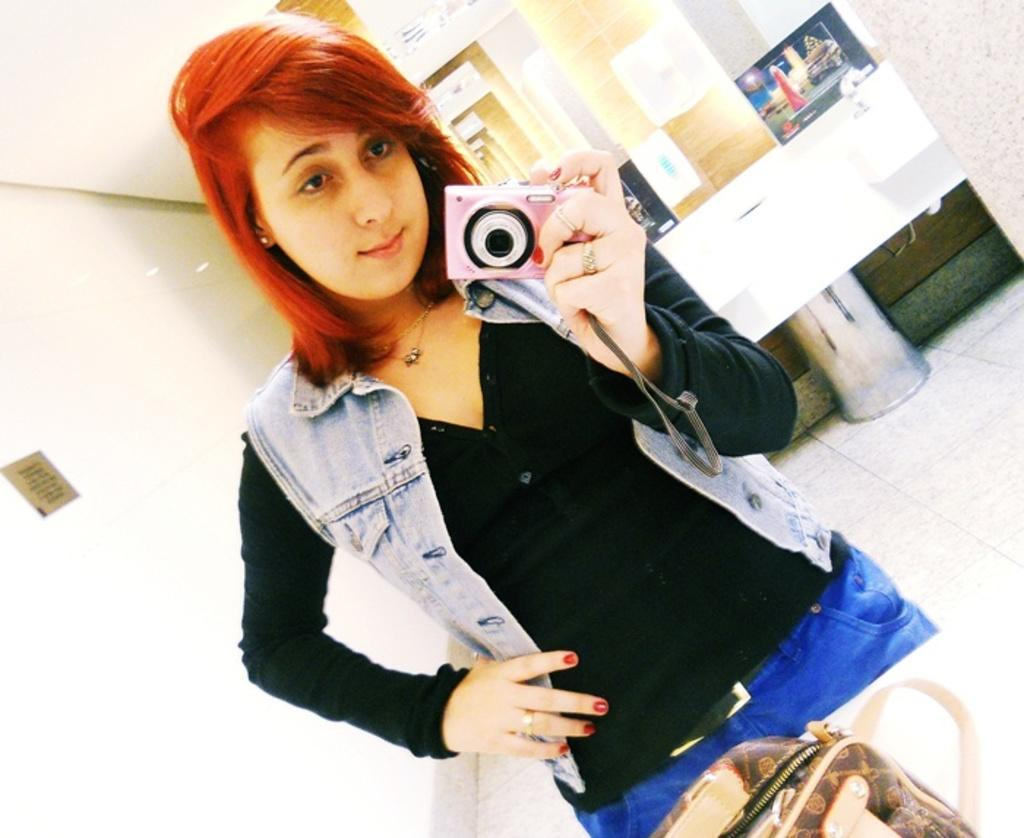Who is present in the image? There is a woman in the image. What is the woman holding in her hand? The woman is holding a digital camera in her hand. What type of flag is visible in the image? There is no flag present in the image. What kind of patch can be seen on the woman's clothing in the image? There is no patch visible on the woman's clothing in the image. 